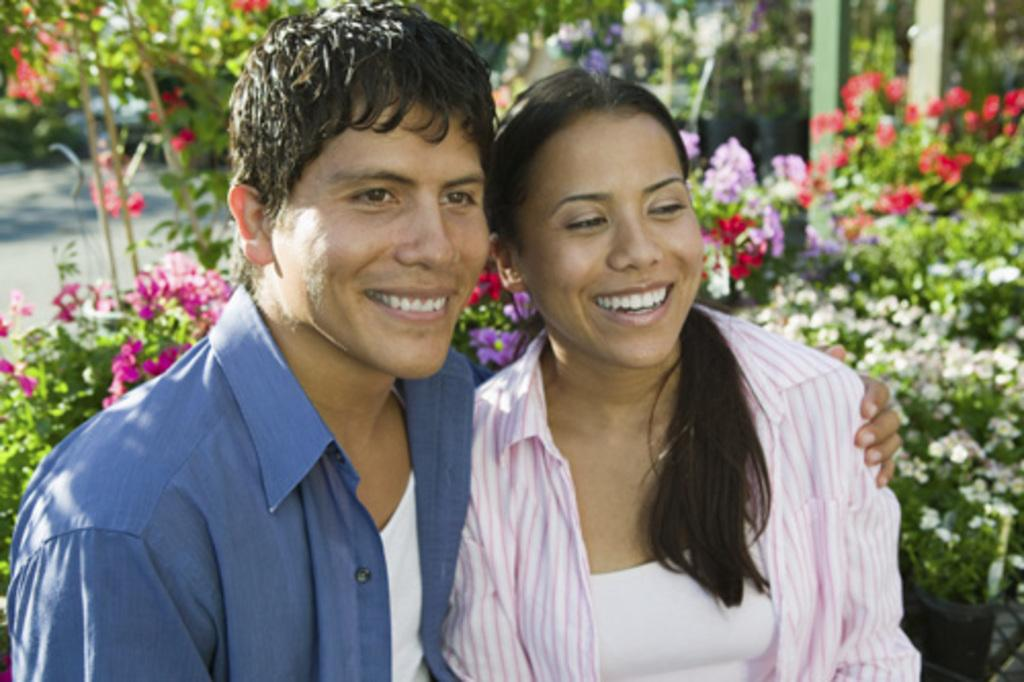How many persons are in the image? There are two persons in the image. What are the two persons doing in the image? The two persons are sitting. What expressions do the two persons have in the image? The two persons are smiling. What can be seen in the background of the image? There are plants and flowers in the background of the image. What type of metal is the degree made of in the image? There is no degree present in the image. What type of voyage are the two persons embarking on in the image? There is no indication of a voyage in the image; the two persons are simply sitting and smiling. 